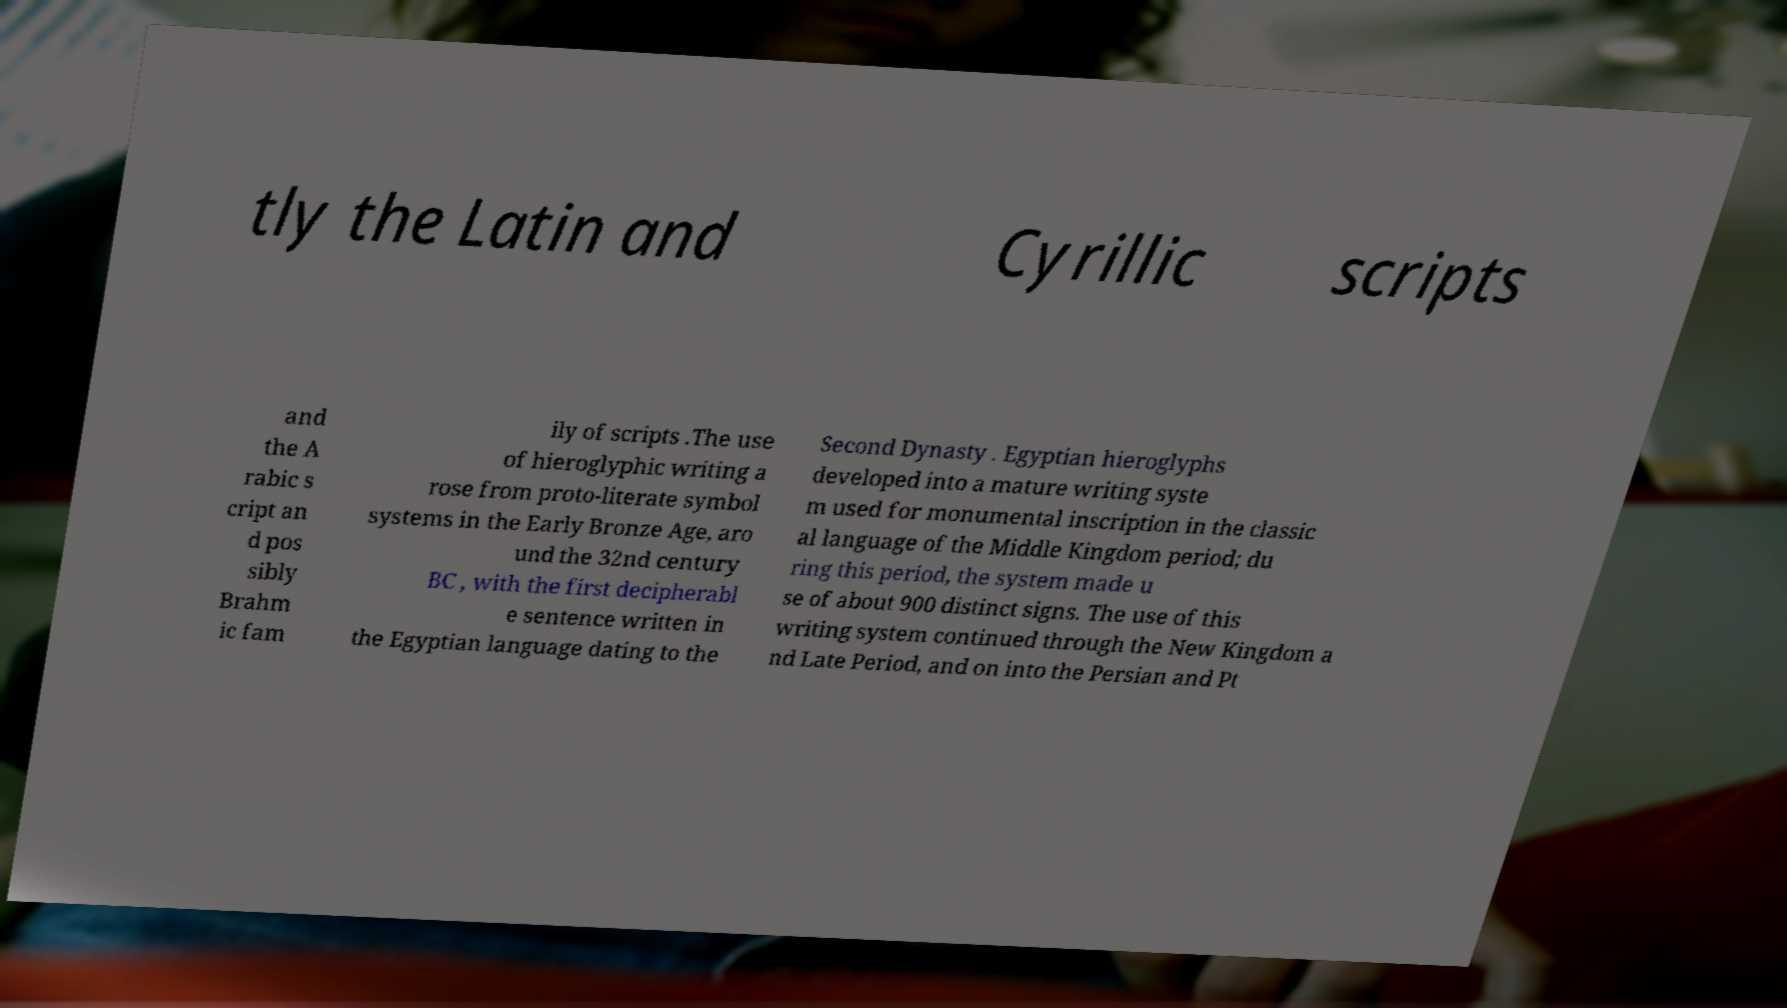Could you extract and type out the text from this image? tly the Latin and Cyrillic scripts and the A rabic s cript an d pos sibly Brahm ic fam ily of scripts .The use of hieroglyphic writing a rose from proto-literate symbol systems in the Early Bronze Age, aro und the 32nd century BC , with the first decipherabl e sentence written in the Egyptian language dating to the Second Dynasty . Egyptian hieroglyphs developed into a mature writing syste m used for monumental inscription in the classic al language of the Middle Kingdom period; du ring this period, the system made u se of about 900 distinct signs. The use of this writing system continued through the New Kingdom a nd Late Period, and on into the Persian and Pt 